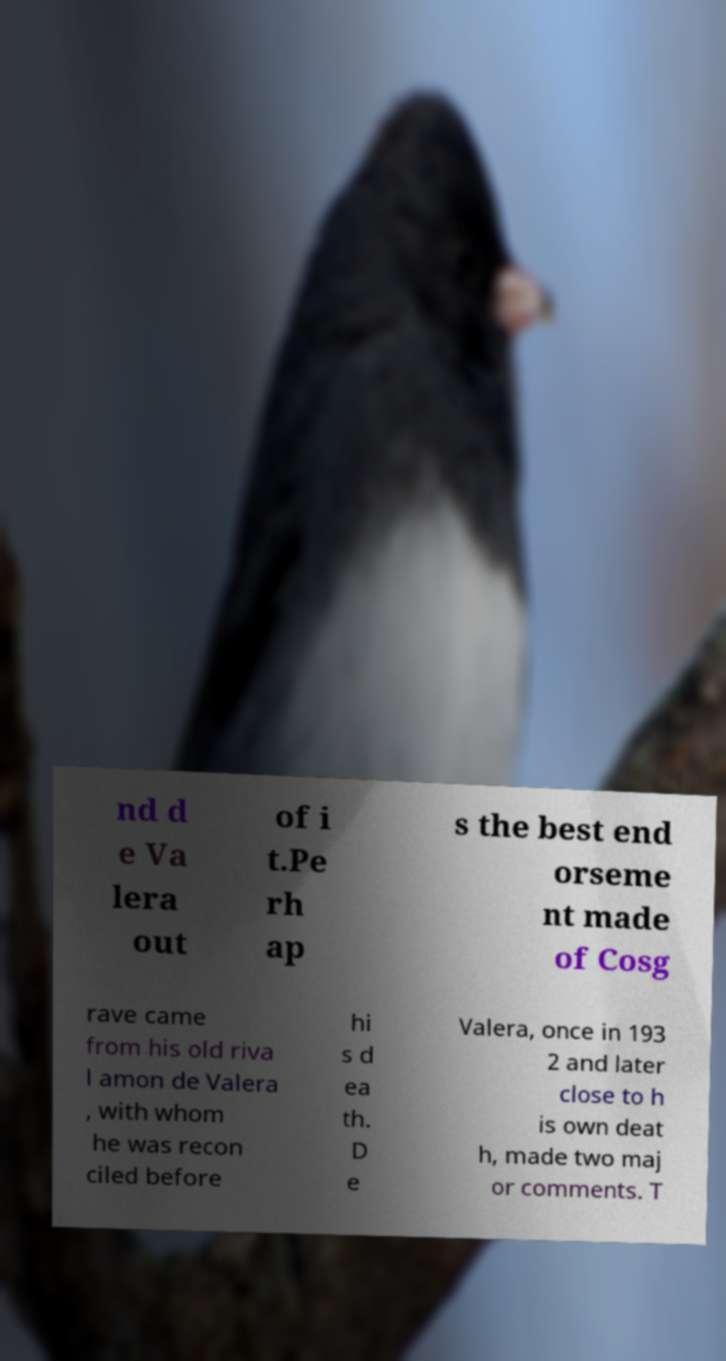For documentation purposes, I need the text within this image transcribed. Could you provide that? nd d e Va lera out of i t.Pe rh ap s the best end orseme nt made of Cosg rave came from his old riva l amon de Valera , with whom he was recon ciled before hi s d ea th. D e Valera, once in 193 2 and later close to h is own deat h, made two maj or comments. T 